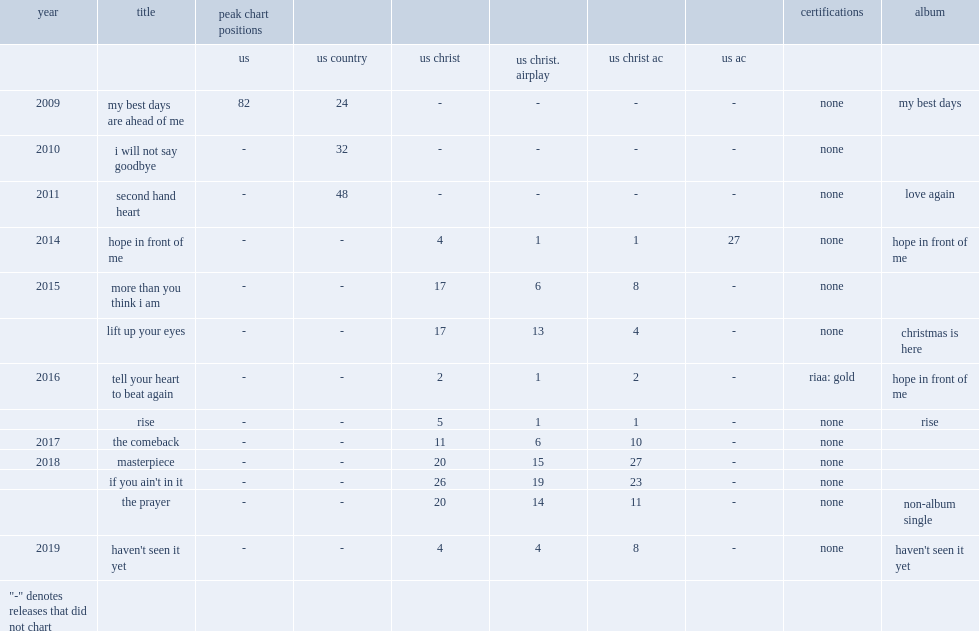When did the single "hope in front of me" release? 2014.0. 